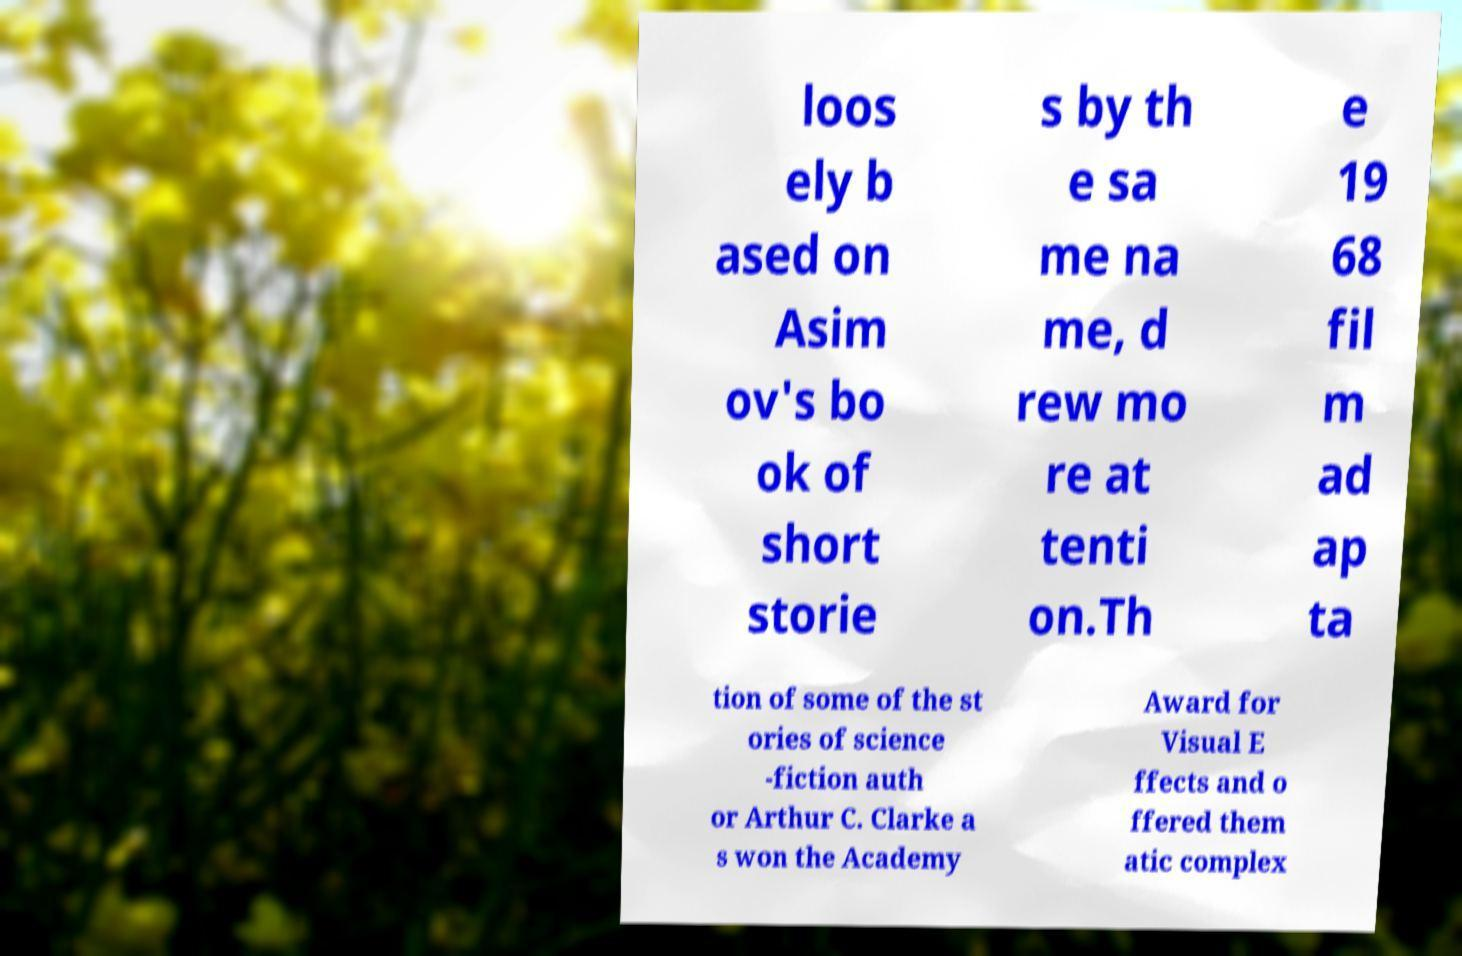Can you accurately transcribe the text from the provided image for me? loos ely b ased on Asim ov's bo ok of short storie s by th e sa me na me, d rew mo re at tenti on.Th e 19 68 fil m ad ap ta tion of some of the st ories of science -fiction auth or Arthur C. Clarke a s won the Academy Award for Visual E ffects and o ffered them atic complex 